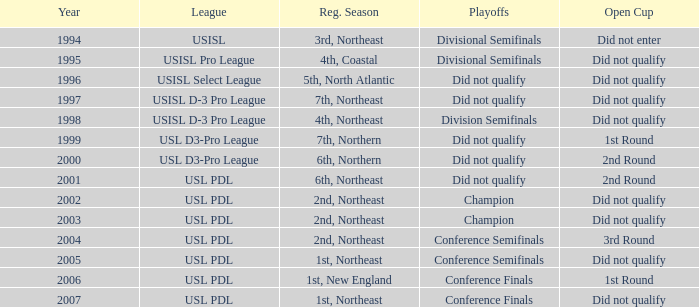Name the playoffs for  usisl select league Did not qualify. 